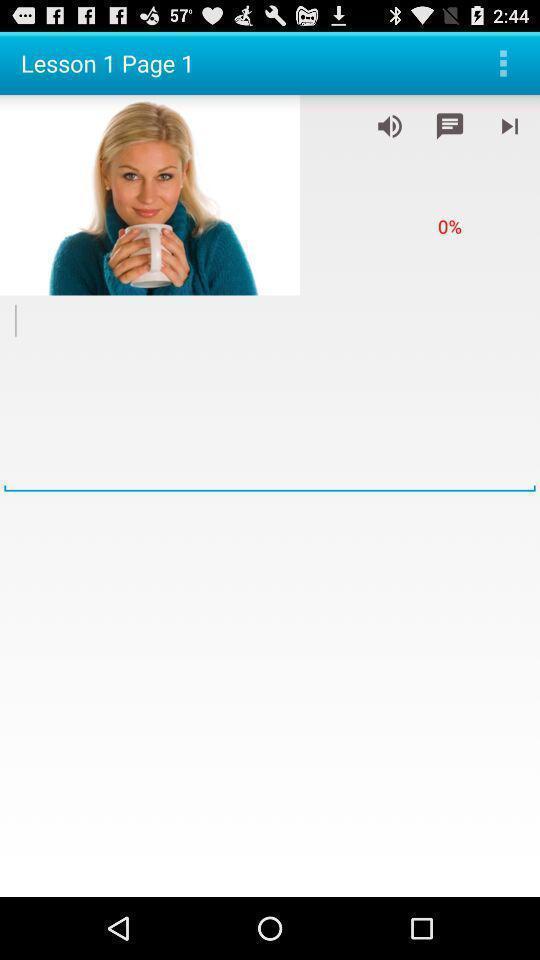What can you discern from this picture? Page showing the image of a woman. 